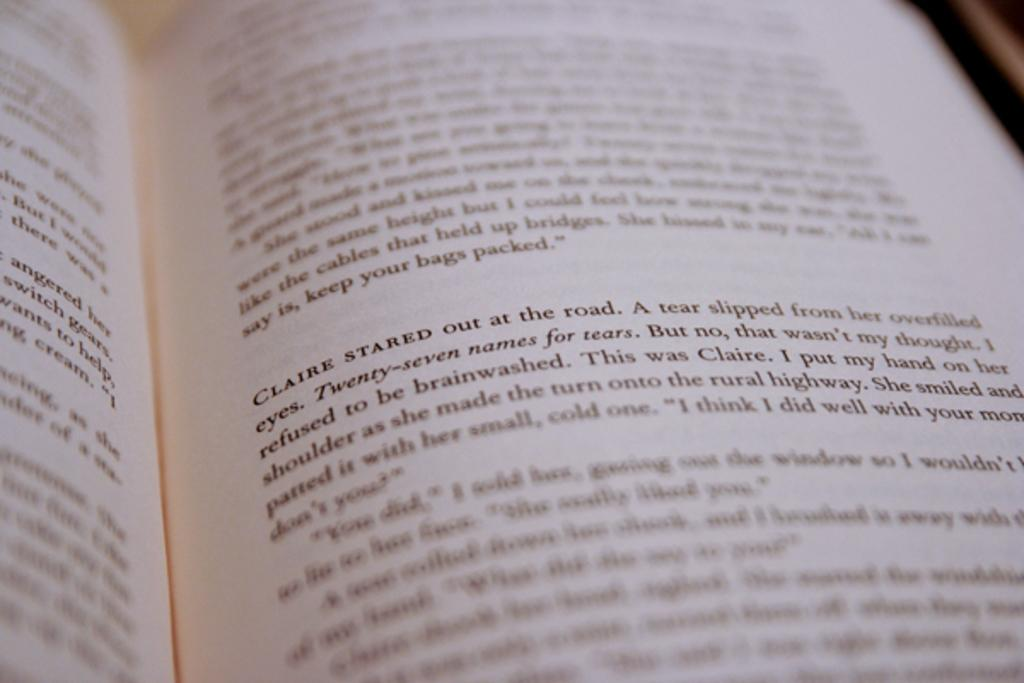<image>
Describe the image concisely. the name Claire is on a book that is black and white 